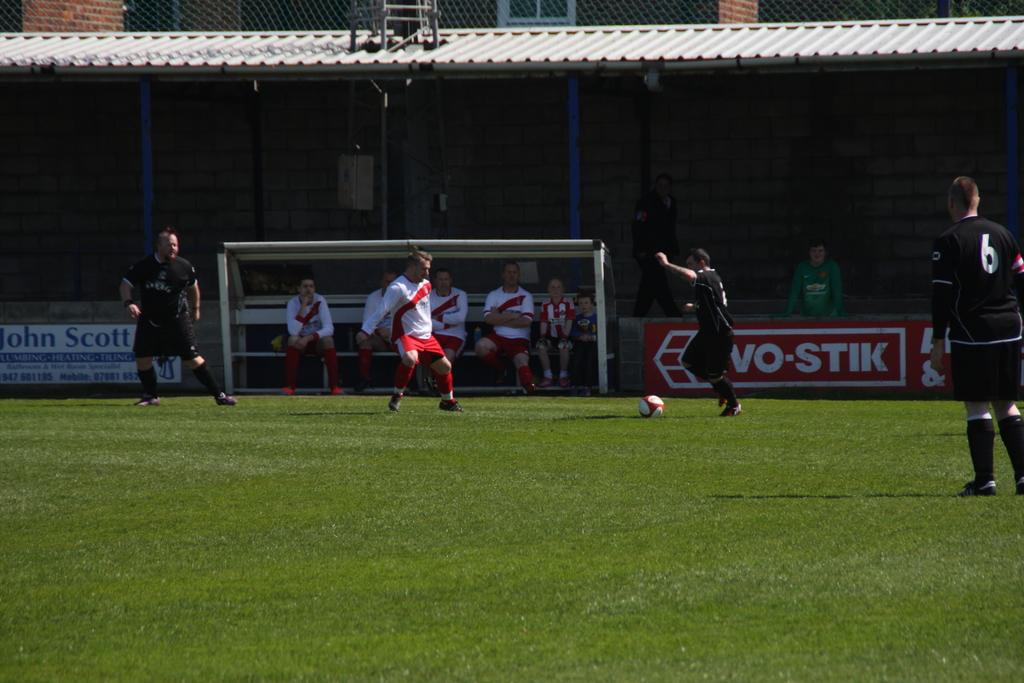Provide a one-sentence caption for the provided image. Soccer players on a field, with one of the black jerseys has the number 6. 